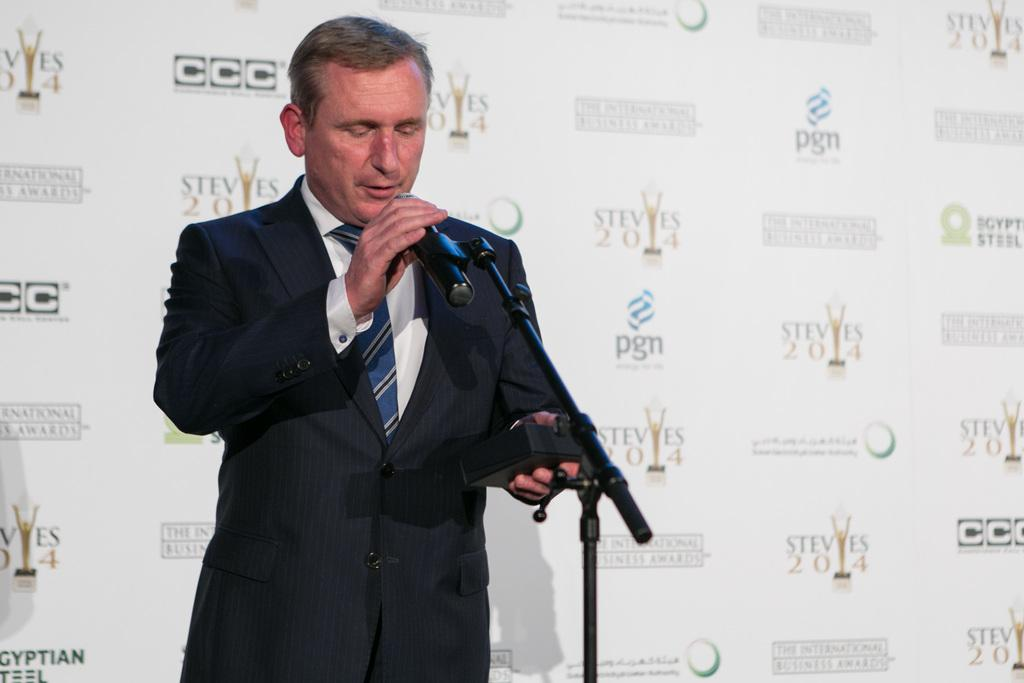What is the person in the image wearing? The person is wearing a black suit. What is the person holding in their right hand? The person is holding a microphone in their right hand. What can be seen in the background of the image? There is a white sheet in the background of the image. What is written on the white sheet? Words are written on the white sheet. What type of bread is being used to cover the box in the image? There is no bread or box present in the image. 